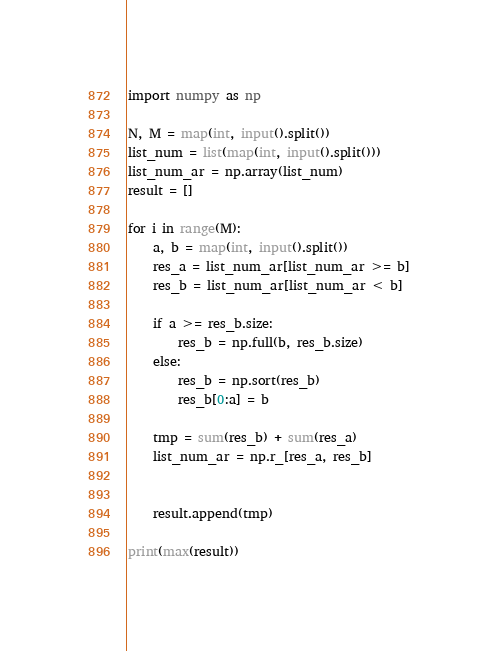Convert code to text. <code><loc_0><loc_0><loc_500><loc_500><_Python_>import numpy as np

N, M = map(int, input().split())
list_num = list(map(int, input().split()))
list_num_ar = np.array(list_num)
result = []

for i in range(M):
	a, b = map(int, input().split())
	res_a = list_num_ar[list_num_ar >= b]
	res_b = list_num_ar[list_num_ar < b]

	if a >= res_b.size:
		res_b = np.full(b, res_b.size)
	else:
		res_b = np.sort(res_b)
		res_b[0:a] = b

	tmp = sum(res_b) + sum(res_a)
	list_num_ar = np.r_[res_a, res_b]


	result.append(tmp)

print(max(result))</code> 